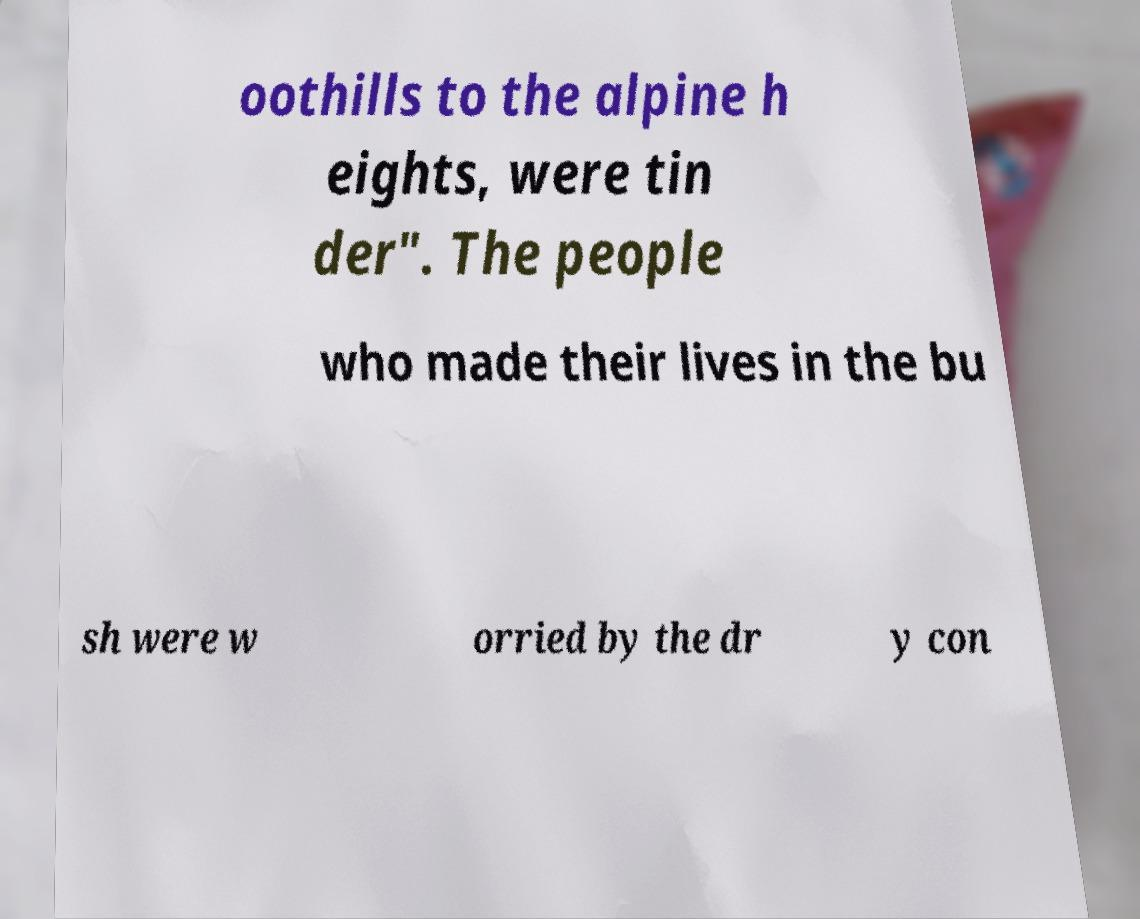For documentation purposes, I need the text within this image transcribed. Could you provide that? oothills to the alpine h eights, were tin der". The people who made their lives in the bu sh were w orried by the dr y con 